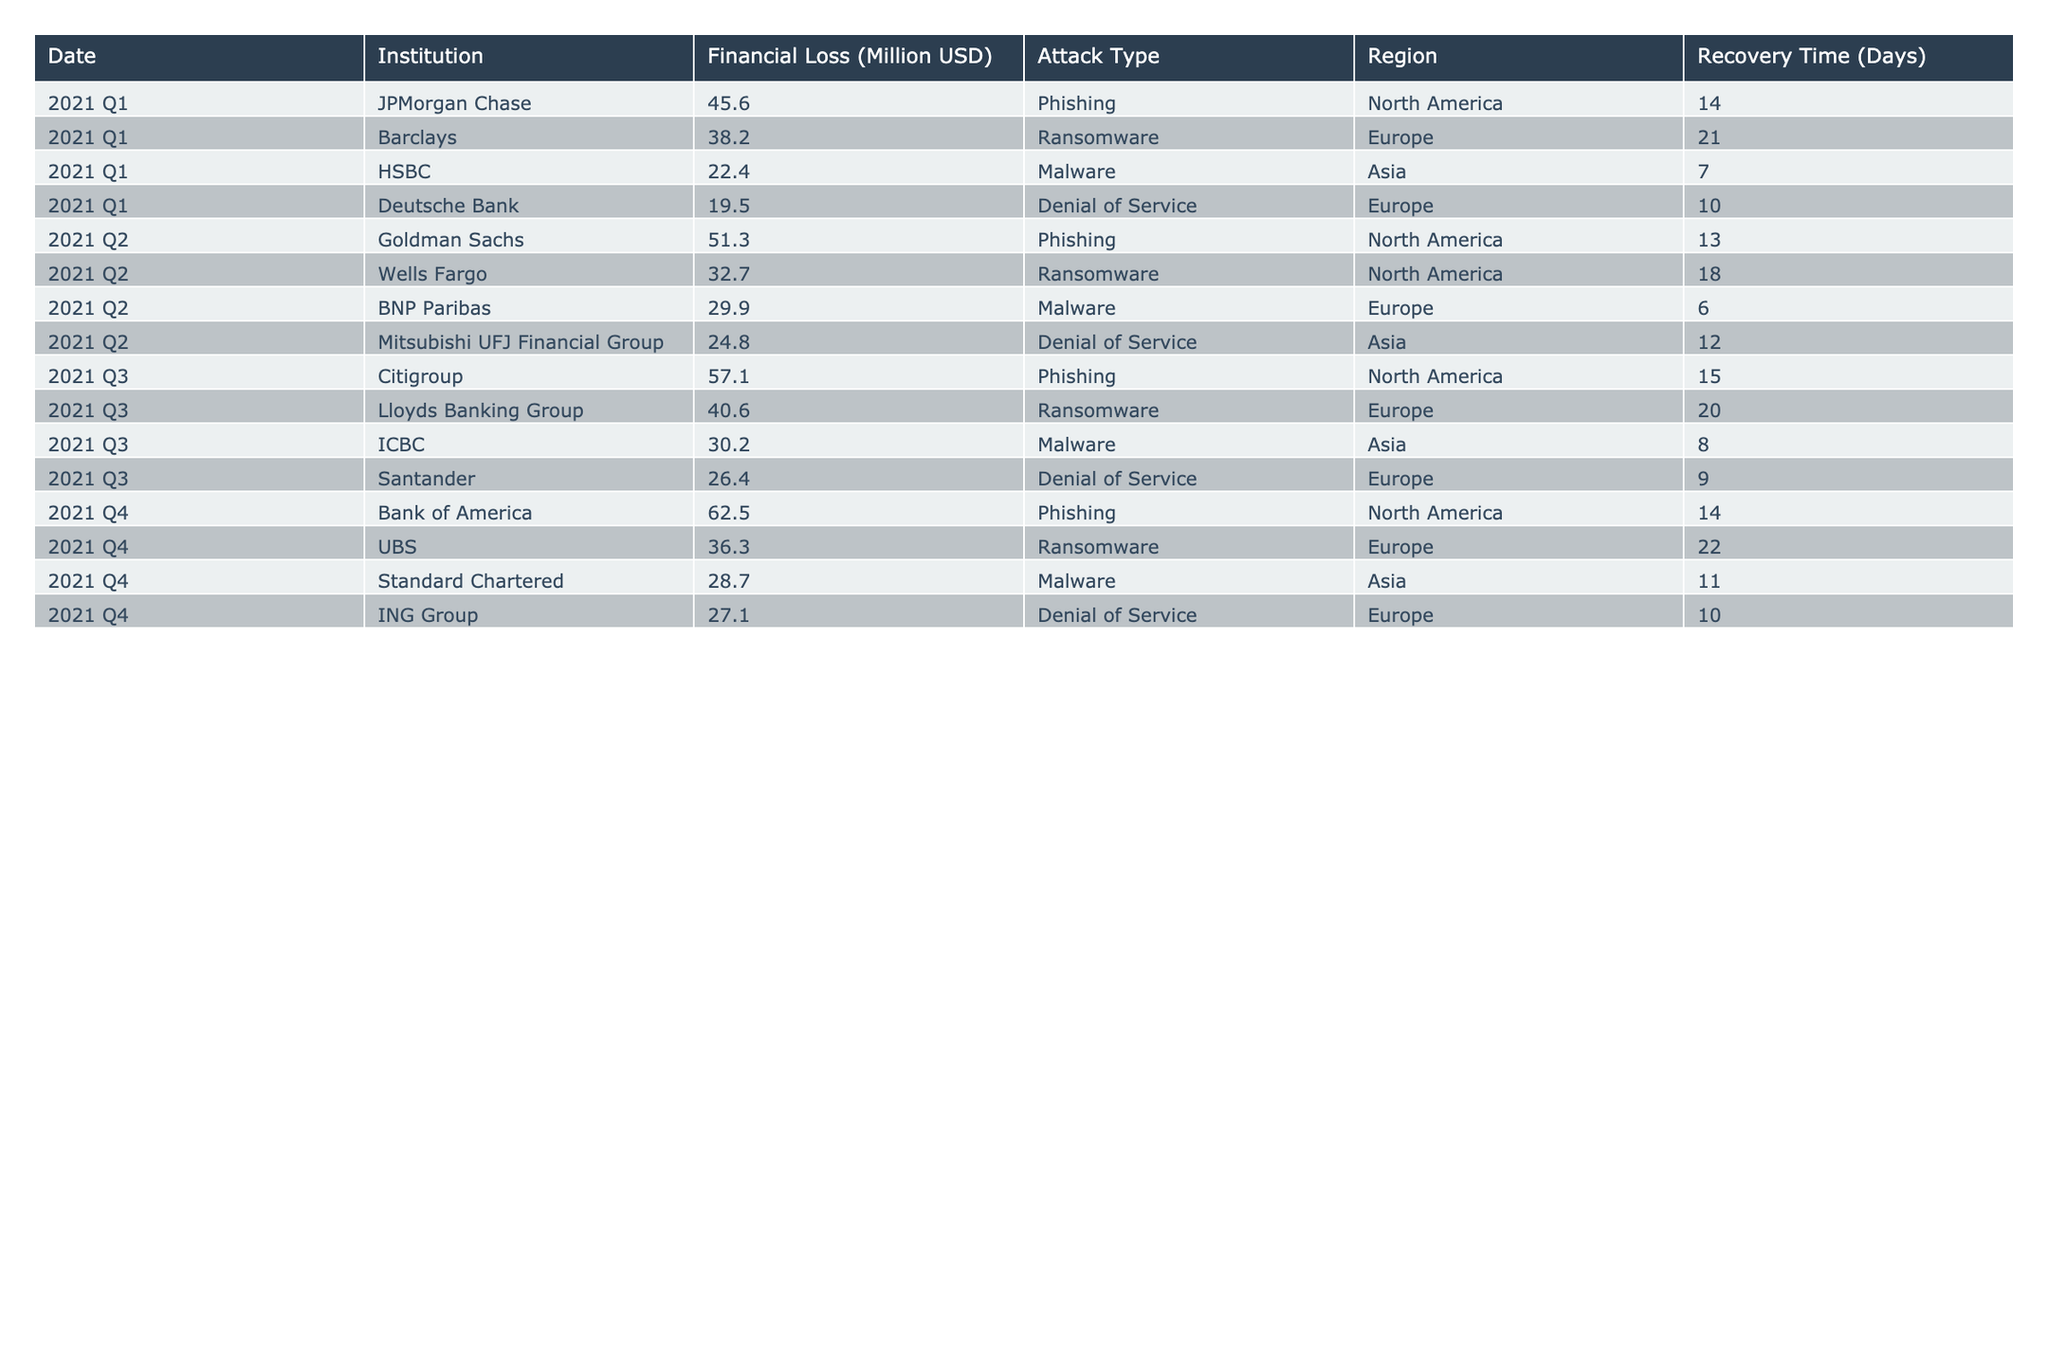What was the financial loss for Barclays in 2021 Q1? The table shows that Barclays had a financial loss of 38.2 million USD in 2021 Q1.
Answer: 38.2 million USD Which banking institution reported the highest financial loss in 2021 Q4? The table indicates that Bank of America reported the highest financial loss of 62.5 million USD in 2021 Q4.
Answer: Bank of America What is the average financial loss across all institutions in 2021 Q2? To find the average financial loss for Q2, we sum the losses: (51.3 + 32.7 + 29.9 + 24.8) = 138.7 million USD. There are 4 institutions, so the average is 138.7 / 4 = 34.675 million USD.
Answer: 34.675 million USD Did any institution in the Asia region experience a financial loss due to Phishing attacks? Reviewing the table, there are no institutions in the Asia region listed with Phishing as the attack type. Thus, the answer is no.
Answer: No What was the total financial loss due to Ransomware attacks across all quarters? The table shows the Ransomware losses for each quarter: 38.2 (Q1) + 32.7 (Q2) + 40.6 (Q3) + 36.3 (Q4) = 147.8 million USD in total.
Answer: 147.8 million USD Which quarter saw the lowest recovery time for a cyber attack? The recovery times listed are: 14 days (JPMorgan Chase, Q1), 13 days (Goldman Sachs, Q2), 15 days (Citigroup, Q3), and 14 days (Bank of America, Q4). The lowest recovery time is 6 days for BNP Paribas in Q2.
Answer: 6 days Was the financial loss due to Denial of Service attacks generally lower than that due to Malware attacks? To determine this, we sum the financial losses for both attack types. Denial of Service losses: 19.5 (Q1) + 24.8 (Q2) + 26.4 (Q3) + 27.1 (Q4) = 97.8 million USD. Malware losses: 22.4 (Q1) + 29.9 (Q2) + 30.2 (Q3) + 28.7 (Q4) = 111.2 million USD. Since 97.8 million is lower than 111.2 million, the answer is yes.
Answer: Yes 